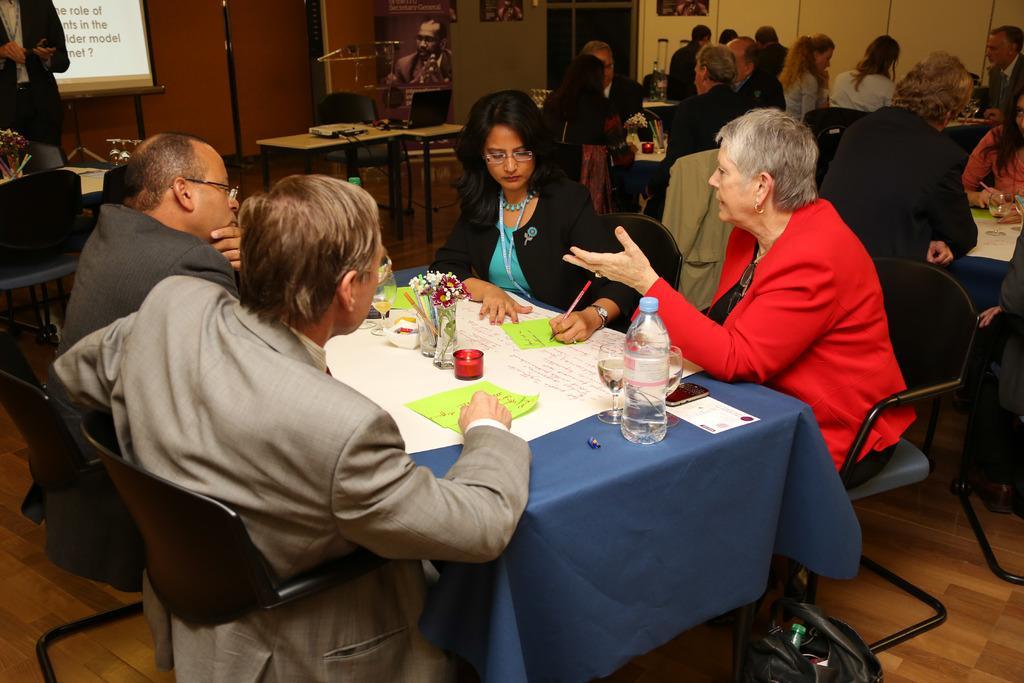How would you summarize this image in a sentence or two? In this image people are arranged in groups. Each group consists of four members. Each group is arranged at a table separately. 